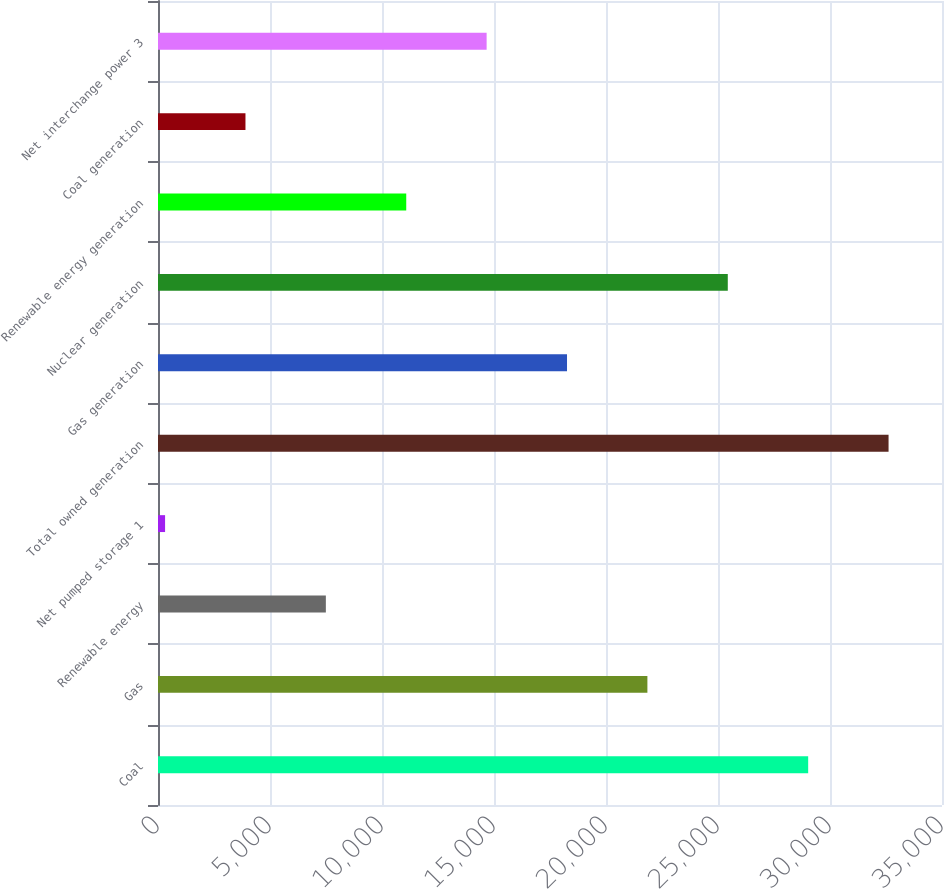<chart> <loc_0><loc_0><loc_500><loc_500><bar_chart><fcel>Coal<fcel>Gas<fcel>Renewable energy<fcel>Net pumped storage 1<fcel>Total owned generation<fcel>Gas generation<fcel>Nuclear generation<fcel>Renewable energy generation<fcel>Coal generation<fcel>Net interchange power 3<nl><fcel>29025.6<fcel>21848.2<fcel>7493.4<fcel>316<fcel>32614.3<fcel>18259.5<fcel>25436.9<fcel>11082.1<fcel>3904.7<fcel>14670.8<nl></chart> 